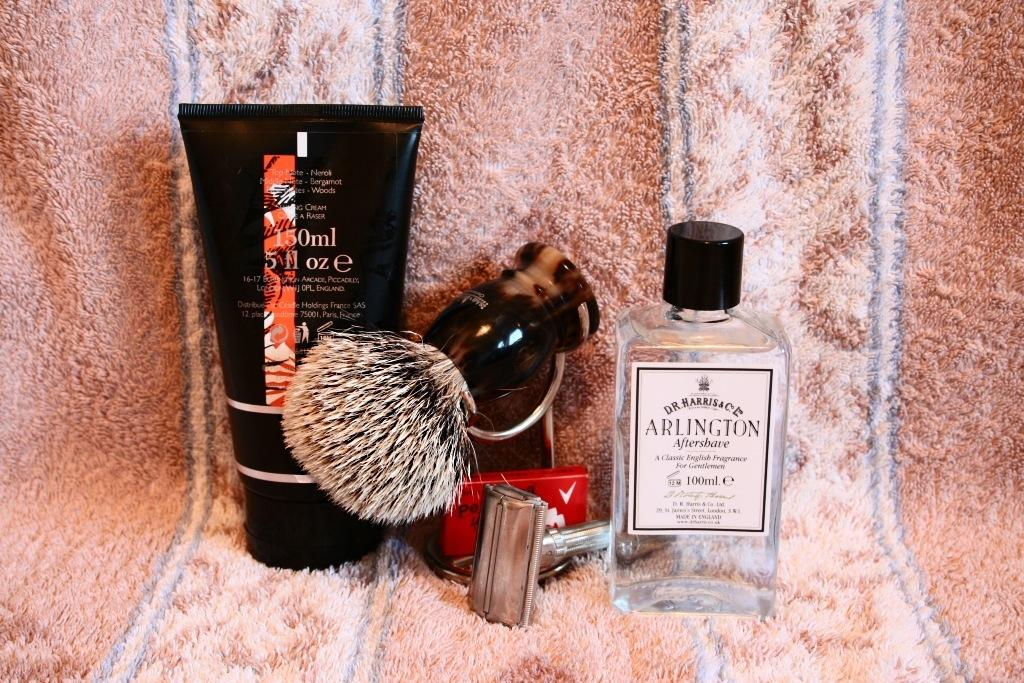<image>
Create a compact narrative representing the image presented. A collection of shaving products includes a bottle of Arlington after shave. 